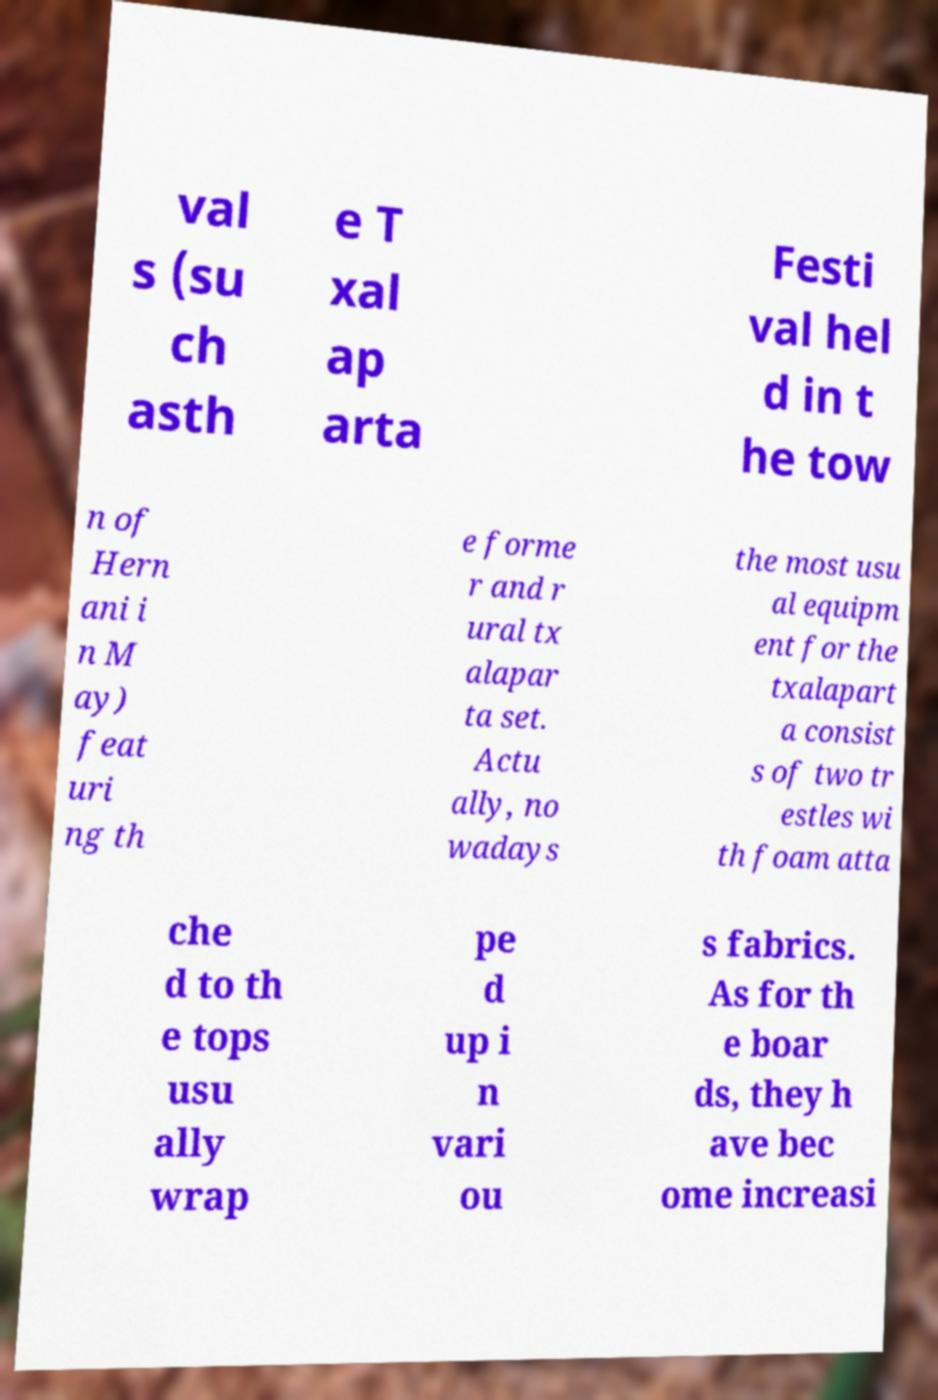Please read and relay the text visible in this image. What does it say? val s (su ch asth e T xal ap arta Festi val hel d in t he tow n of Hern ani i n M ay) feat uri ng th e forme r and r ural tx alapar ta set. Actu ally, no wadays the most usu al equipm ent for the txalapart a consist s of two tr estles wi th foam atta che d to th e tops usu ally wrap pe d up i n vari ou s fabrics. As for th e boar ds, they h ave bec ome increasi 